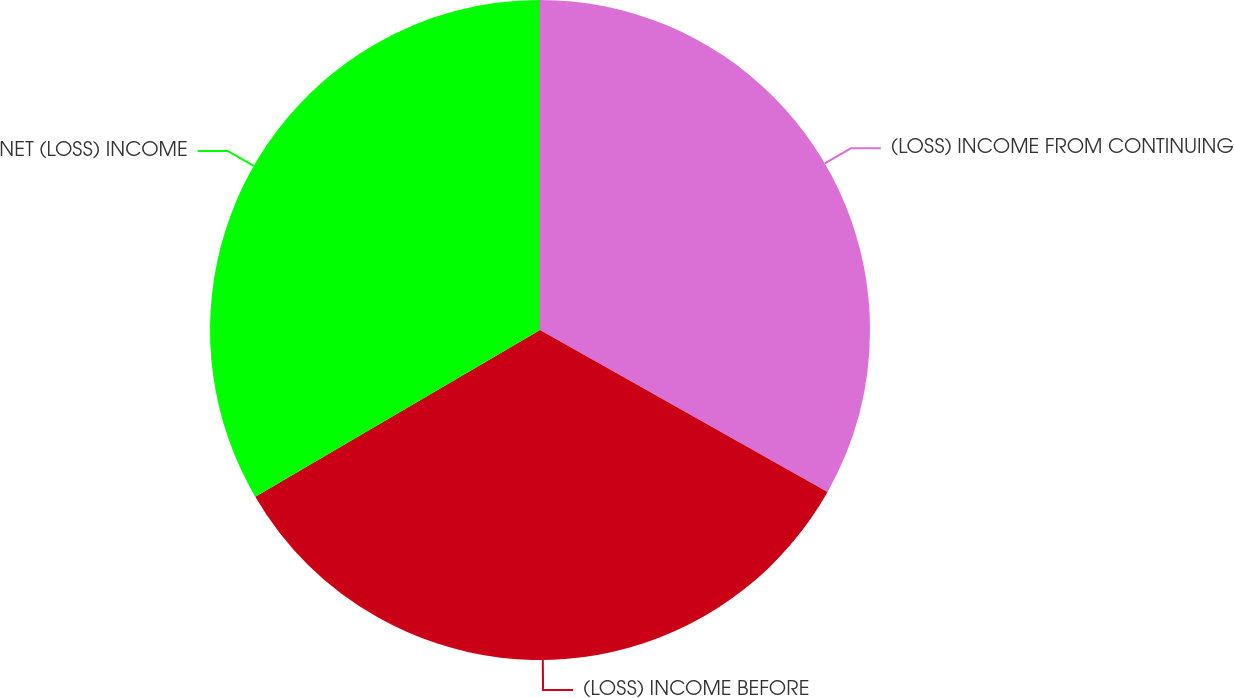Convert chart to OTSL. <chart><loc_0><loc_0><loc_500><loc_500><pie_chart><fcel>(LOSS) INCOME FROM CONTINUING<fcel>(LOSS) INCOME BEFORE<fcel>NET (LOSS) INCOME<nl><fcel>33.16%<fcel>33.41%<fcel>33.43%<nl></chart> 